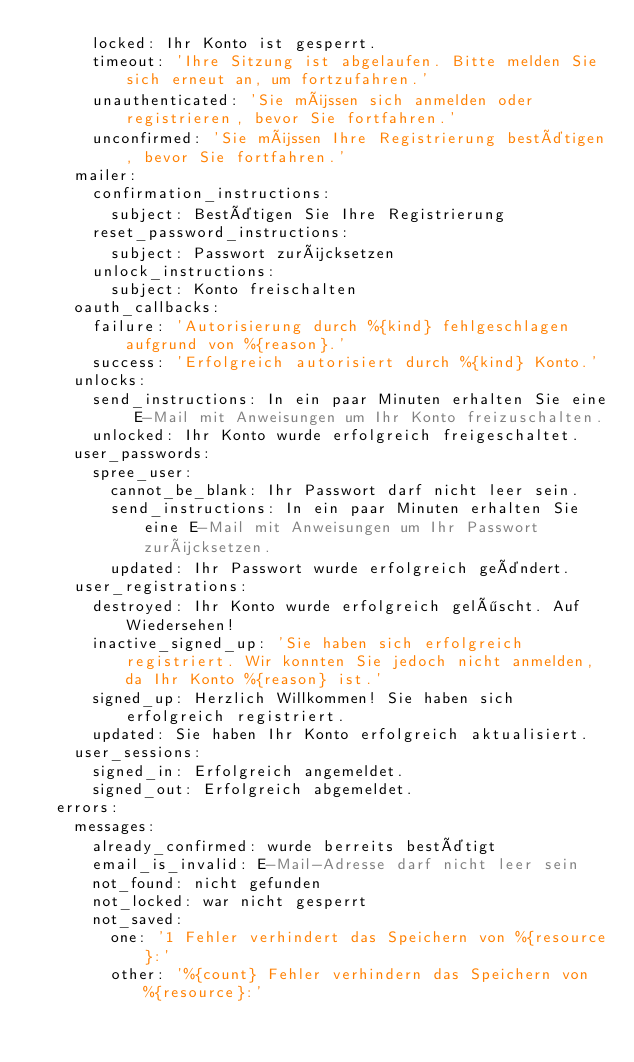<code> <loc_0><loc_0><loc_500><loc_500><_YAML_>      locked: Ihr Konto ist gesperrt.
      timeout: 'Ihre Sitzung ist abgelaufen. Bitte melden Sie sich erneut an, um fortzufahren.'
      unauthenticated: 'Sie müssen sich anmelden oder registrieren, bevor Sie fortfahren.'
      unconfirmed: 'Sie müssen Ihre Registrierung bestätigen, bevor Sie fortfahren.'
    mailer:
      confirmation_instructions:
        subject: Bestätigen Sie Ihre Registrierung
      reset_password_instructions:
        subject: Passwort zurücksetzen
      unlock_instructions:
        subject: Konto freischalten
    oauth_callbacks:
      failure: 'Autorisierung durch %{kind} fehlgeschlagen aufgrund von %{reason}.'
      success: 'Erfolgreich autorisiert durch %{kind} Konto.'
    unlocks:
      send_instructions: In ein paar Minuten erhalten Sie eine E-Mail mit Anweisungen um Ihr Konto freizuschalten.
      unlocked: Ihr Konto wurde erfolgreich freigeschaltet.
    user_passwords:
      spree_user:
        cannot_be_blank: Ihr Passwort darf nicht leer sein.
        send_instructions: In ein paar Minuten erhalten Sie eine E-Mail mit Anweisungen um Ihr Passwort zurücksetzen.
        updated: Ihr Passwort wurde erfolgreich geändert.
    user_registrations:
      destroyed: Ihr Konto wurde erfolgreich gelöscht. Auf Wiedersehen!
      inactive_signed_up: 'Sie haben sich erfolgreich registriert. Wir konnten Sie jedoch nicht anmelden, da Ihr Konto %{reason} ist.'
      signed_up: Herzlich Willkommen! Sie haben sich erfolgreich registriert.
      updated: Sie haben Ihr Konto erfolgreich aktualisiert.
    user_sessions:
      signed_in: Erfolgreich angemeldet.
      signed_out: Erfolgreich abgemeldet.
  errors:
    messages:
      already_confirmed: wurde berreits bestätigt
      email_is_invalid: E-Mail-Adresse darf nicht leer sein
      not_found: nicht gefunden
      not_locked: war nicht gesperrt
      not_saved:
        one: '1 Fehler verhindert das Speichern von %{resource}:'
        other: '%{count} Fehler verhindern das Speichern von %{resource}:'
</code> 